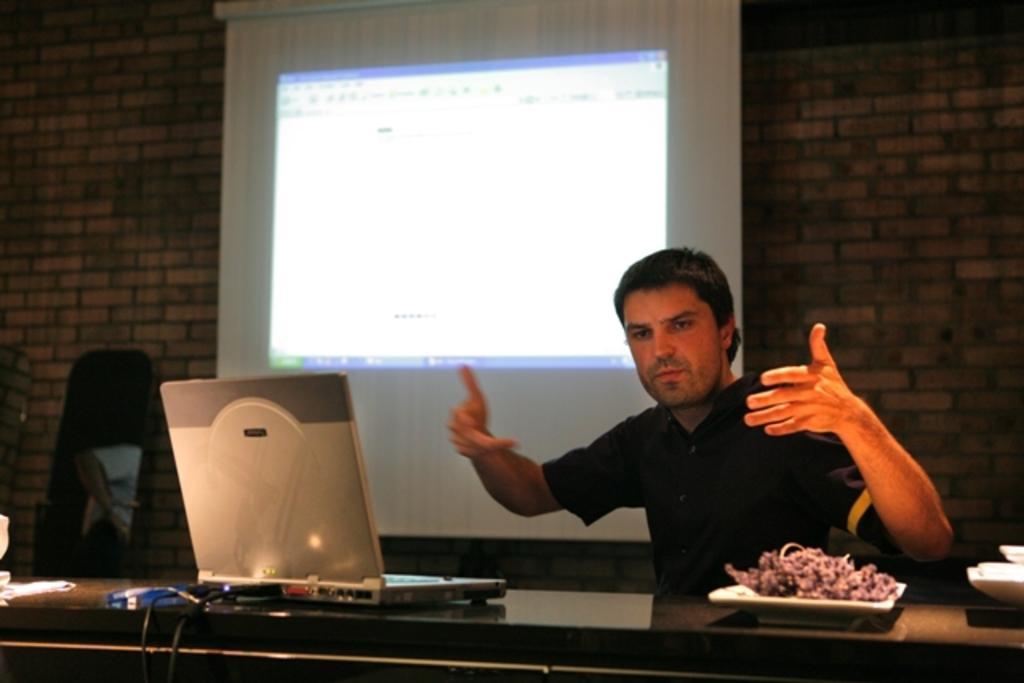Can you describe this image briefly? In this image, we can see a laptop with cables and there is food on the plate and we can see some other objects on the table. In the background, there is a person, screen and we can see a wall. On the left, there is an object which is in black color. 